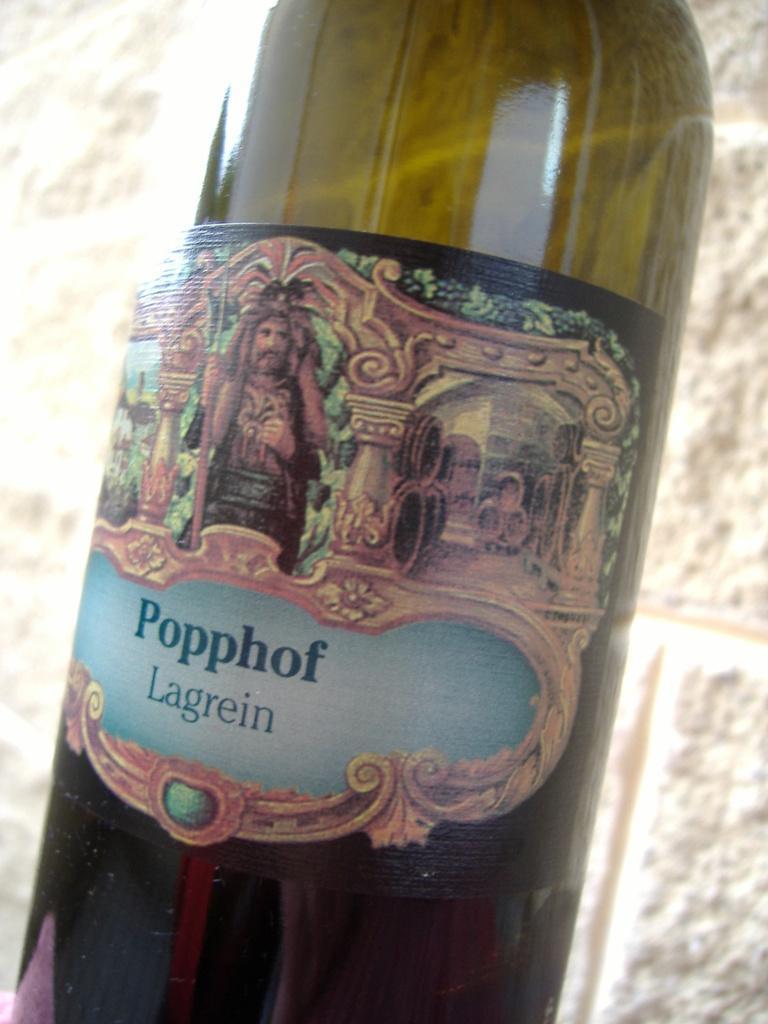Could you give a brief overview of what you see in this image? This image contains a bottle which is labelled as poppof lagerain. It consists a man image on that label. Behind the bottle is a brick wall 